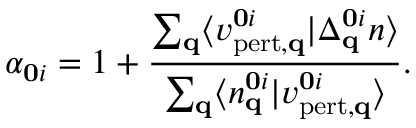<formula> <loc_0><loc_0><loc_500><loc_500>\alpha _ { 0 i } = 1 + \frac { \sum _ { q } \langle v _ { p e r t , q } ^ { 0 i } | \Delta _ { q } ^ { 0 i } n \rangle } { \sum _ { q } \langle n _ { q } ^ { 0 i } | v _ { p e r t , q } ^ { 0 i } \rangle } .</formula> 